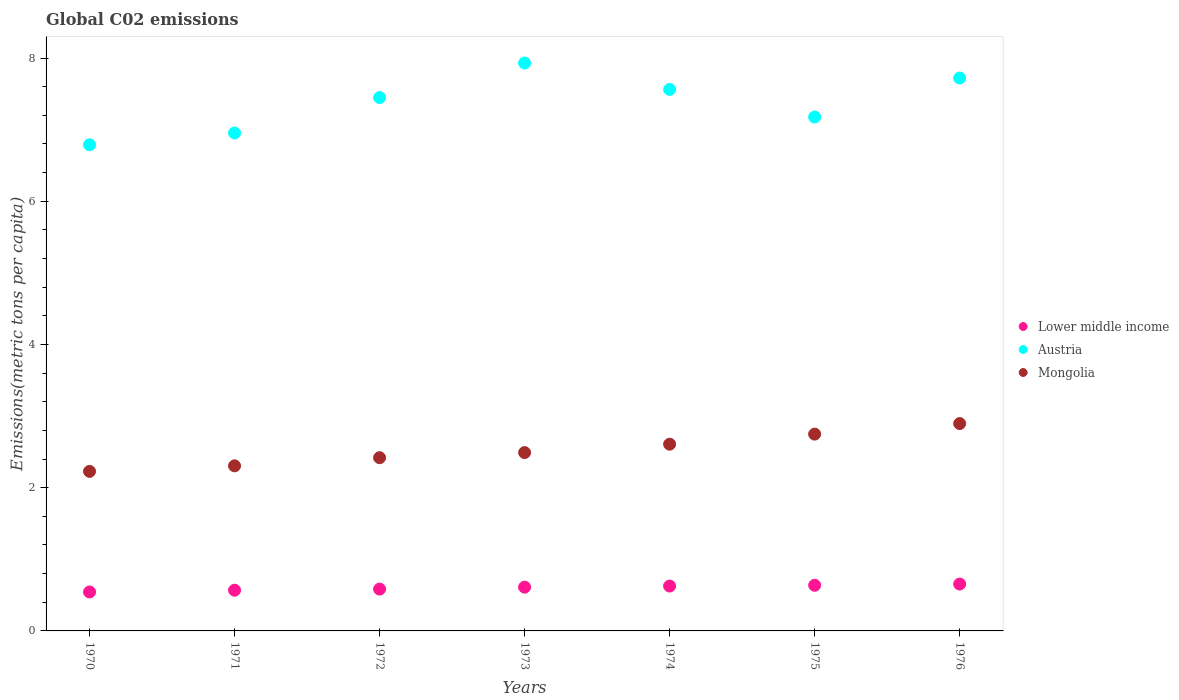What is the amount of CO2 emitted in in Lower middle income in 1975?
Provide a succinct answer. 0.64. Across all years, what is the maximum amount of CO2 emitted in in Mongolia?
Ensure brevity in your answer.  2.9. Across all years, what is the minimum amount of CO2 emitted in in Mongolia?
Offer a terse response. 2.23. In which year was the amount of CO2 emitted in in Lower middle income maximum?
Your response must be concise. 1976. What is the total amount of CO2 emitted in in Lower middle income in the graph?
Offer a very short reply. 4.23. What is the difference between the amount of CO2 emitted in in Mongolia in 1970 and that in 1974?
Make the answer very short. -0.38. What is the difference between the amount of CO2 emitted in in Austria in 1973 and the amount of CO2 emitted in in Mongolia in 1974?
Ensure brevity in your answer.  5.32. What is the average amount of CO2 emitted in in Austria per year?
Provide a succinct answer. 7.37. In the year 1975, what is the difference between the amount of CO2 emitted in in Mongolia and amount of CO2 emitted in in Austria?
Provide a succinct answer. -4.43. What is the ratio of the amount of CO2 emitted in in Lower middle income in 1971 to that in 1973?
Your answer should be compact. 0.93. Is the difference between the amount of CO2 emitted in in Mongolia in 1971 and 1976 greater than the difference between the amount of CO2 emitted in in Austria in 1971 and 1976?
Ensure brevity in your answer.  Yes. What is the difference between the highest and the second highest amount of CO2 emitted in in Lower middle income?
Offer a terse response. 0.02. What is the difference between the highest and the lowest amount of CO2 emitted in in Austria?
Your answer should be compact. 1.14. Is the sum of the amount of CO2 emitted in in Lower middle income in 1971 and 1975 greater than the maximum amount of CO2 emitted in in Mongolia across all years?
Provide a short and direct response. No. Is the amount of CO2 emitted in in Lower middle income strictly less than the amount of CO2 emitted in in Mongolia over the years?
Your answer should be very brief. Yes. How many years are there in the graph?
Provide a short and direct response. 7. What is the difference between two consecutive major ticks on the Y-axis?
Offer a terse response. 2. Are the values on the major ticks of Y-axis written in scientific E-notation?
Offer a very short reply. No. Does the graph contain grids?
Ensure brevity in your answer.  No. Where does the legend appear in the graph?
Offer a terse response. Center right. What is the title of the graph?
Provide a short and direct response. Global C02 emissions. What is the label or title of the X-axis?
Provide a succinct answer. Years. What is the label or title of the Y-axis?
Offer a terse response. Emissions(metric tons per capita). What is the Emissions(metric tons per capita) in Lower middle income in 1970?
Provide a succinct answer. 0.54. What is the Emissions(metric tons per capita) in Austria in 1970?
Keep it short and to the point. 6.79. What is the Emissions(metric tons per capita) of Mongolia in 1970?
Ensure brevity in your answer.  2.23. What is the Emissions(metric tons per capita) of Lower middle income in 1971?
Keep it short and to the point. 0.57. What is the Emissions(metric tons per capita) of Austria in 1971?
Keep it short and to the point. 6.95. What is the Emissions(metric tons per capita) of Mongolia in 1971?
Ensure brevity in your answer.  2.31. What is the Emissions(metric tons per capita) of Lower middle income in 1972?
Your answer should be compact. 0.58. What is the Emissions(metric tons per capita) in Austria in 1972?
Make the answer very short. 7.45. What is the Emissions(metric tons per capita) in Mongolia in 1972?
Your response must be concise. 2.42. What is the Emissions(metric tons per capita) in Lower middle income in 1973?
Your answer should be very brief. 0.61. What is the Emissions(metric tons per capita) of Austria in 1973?
Make the answer very short. 7.93. What is the Emissions(metric tons per capita) in Mongolia in 1973?
Your response must be concise. 2.49. What is the Emissions(metric tons per capita) in Lower middle income in 1974?
Your response must be concise. 0.63. What is the Emissions(metric tons per capita) in Austria in 1974?
Keep it short and to the point. 7.56. What is the Emissions(metric tons per capita) of Mongolia in 1974?
Provide a short and direct response. 2.61. What is the Emissions(metric tons per capita) of Lower middle income in 1975?
Offer a terse response. 0.64. What is the Emissions(metric tons per capita) in Austria in 1975?
Make the answer very short. 7.18. What is the Emissions(metric tons per capita) in Mongolia in 1975?
Keep it short and to the point. 2.75. What is the Emissions(metric tons per capita) in Lower middle income in 1976?
Offer a very short reply. 0.65. What is the Emissions(metric tons per capita) of Austria in 1976?
Your answer should be compact. 7.72. What is the Emissions(metric tons per capita) of Mongolia in 1976?
Give a very brief answer. 2.9. Across all years, what is the maximum Emissions(metric tons per capita) in Lower middle income?
Make the answer very short. 0.65. Across all years, what is the maximum Emissions(metric tons per capita) of Austria?
Give a very brief answer. 7.93. Across all years, what is the maximum Emissions(metric tons per capita) of Mongolia?
Make the answer very short. 2.9. Across all years, what is the minimum Emissions(metric tons per capita) in Lower middle income?
Make the answer very short. 0.54. Across all years, what is the minimum Emissions(metric tons per capita) in Austria?
Offer a terse response. 6.79. Across all years, what is the minimum Emissions(metric tons per capita) of Mongolia?
Give a very brief answer. 2.23. What is the total Emissions(metric tons per capita) of Lower middle income in the graph?
Your answer should be compact. 4.23. What is the total Emissions(metric tons per capita) of Austria in the graph?
Your response must be concise. 51.58. What is the total Emissions(metric tons per capita) in Mongolia in the graph?
Offer a terse response. 17.7. What is the difference between the Emissions(metric tons per capita) in Lower middle income in 1970 and that in 1971?
Provide a succinct answer. -0.02. What is the difference between the Emissions(metric tons per capita) in Austria in 1970 and that in 1971?
Your response must be concise. -0.16. What is the difference between the Emissions(metric tons per capita) in Mongolia in 1970 and that in 1971?
Keep it short and to the point. -0.08. What is the difference between the Emissions(metric tons per capita) in Lower middle income in 1970 and that in 1972?
Offer a very short reply. -0.04. What is the difference between the Emissions(metric tons per capita) of Austria in 1970 and that in 1972?
Your response must be concise. -0.66. What is the difference between the Emissions(metric tons per capita) of Mongolia in 1970 and that in 1972?
Keep it short and to the point. -0.19. What is the difference between the Emissions(metric tons per capita) of Lower middle income in 1970 and that in 1973?
Provide a succinct answer. -0.07. What is the difference between the Emissions(metric tons per capita) of Austria in 1970 and that in 1973?
Give a very brief answer. -1.14. What is the difference between the Emissions(metric tons per capita) of Mongolia in 1970 and that in 1973?
Provide a succinct answer. -0.26. What is the difference between the Emissions(metric tons per capita) of Lower middle income in 1970 and that in 1974?
Provide a short and direct response. -0.08. What is the difference between the Emissions(metric tons per capita) of Austria in 1970 and that in 1974?
Offer a terse response. -0.77. What is the difference between the Emissions(metric tons per capita) of Mongolia in 1970 and that in 1974?
Offer a terse response. -0.38. What is the difference between the Emissions(metric tons per capita) in Lower middle income in 1970 and that in 1975?
Offer a terse response. -0.09. What is the difference between the Emissions(metric tons per capita) in Austria in 1970 and that in 1975?
Your answer should be compact. -0.39. What is the difference between the Emissions(metric tons per capita) in Mongolia in 1970 and that in 1975?
Give a very brief answer. -0.52. What is the difference between the Emissions(metric tons per capita) in Lower middle income in 1970 and that in 1976?
Offer a terse response. -0.11. What is the difference between the Emissions(metric tons per capita) of Austria in 1970 and that in 1976?
Keep it short and to the point. -0.93. What is the difference between the Emissions(metric tons per capita) of Mongolia in 1970 and that in 1976?
Keep it short and to the point. -0.67. What is the difference between the Emissions(metric tons per capita) in Lower middle income in 1971 and that in 1972?
Offer a very short reply. -0.02. What is the difference between the Emissions(metric tons per capita) in Austria in 1971 and that in 1972?
Your answer should be very brief. -0.49. What is the difference between the Emissions(metric tons per capita) of Mongolia in 1971 and that in 1972?
Give a very brief answer. -0.11. What is the difference between the Emissions(metric tons per capita) in Lower middle income in 1971 and that in 1973?
Your answer should be compact. -0.04. What is the difference between the Emissions(metric tons per capita) of Austria in 1971 and that in 1973?
Offer a very short reply. -0.98. What is the difference between the Emissions(metric tons per capita) of Mongolia in 1971 and that in 1973?
Your response must be concise. -0.19. What is the difference between the Emissions(metric tons per capita) in Lower middle income in 1971 and that in 1974?
Make the answer very short. -0.06. What is the difference between the Emissions(metric tons per capita) of Austria in 1971 and that in 1974?
Offer a very short reply. -0.61. What is the difference between the Emissions(metric tons per capita) in Mongolia in 1971 and that in 1974?
Give a very brief answer. -0.3. What is the difference between the Emissions(metric tons per capita) of Lower middle income in 1971 and that in 1975?
Offer a very short reply. -0.07. What is the difference between the Emissions(metric tons per capita) in Austria in 1971 and that in 1975?
Provide a succinct answer. -0.22. What is the difference between the Emissions(metric tons per capita) of Mongolia in 1971 and that in 1975?
Your response must be concise. -0.44. What is the difference between the Emissions(metric tons per capita) of Lower middle income in 1971 and that in 1976?
Your response must be concise. -0.09. What is the difference between the Emissions(metric tons per capita) in Austria in 1971 and that in 1976?
Your answer should be very brief. -0.77. What is the difference between the Emissions(metric tons per capita) of Mongolia in 1971 and that in 1976?
Your response must be concise. -0.59. What is the difference between the Emissions(metric tons per capita) in Lower middle income in 1972 and that in 1973?
Offer a very short reply. -0.03. What is the difference between the Emissions(metric tons per capita) of Austria in 1972 and that in 1973?
Your answer should be compact. -0.48. What is the difference between the Emissions(metric tons per capita) in Mongolia in 1972 and that in 1973?
Keep it short and to the point. -0.07. What is the difference between the Emissions(metric tons per capita) in Lower middle income in 1972 and that in 1974?
Your answer should be compact. -0.04. What is the difference between the Emissions(metric tons per capita) of Austria in 1972 and that in 1974?
Offer a very short reply. -0.11. What is the difference between the Emissions(metric tons per capita) in Mongolia in 1972 and that in 1974?
Your answer should be compact. -0.19. What is the difference between the Emissions(metric tons per capita) of Lower middle income in 1972 and that in 1975?
Make the answer very short. -0.05. What is the difference between the Emissions(metric tons per capita) in Austria in 1972 and that in 1975?
Your answer should be compact. 0.27. What is the difference between the Emissions(metric tons per capita) of Mongolia in 1972 and that in 1975?
Your answer should be very brief. -0.33. What is the difference between the Emissions(metric tons per capita) in Lower middle income in 1972 and that in 1976?
Your response must be concise. -0.07. What is the difference between the Emissions(metric tons per capita) in Austria in 1972 and that in 1976?
Keep it short and to the point. -0.27. What is the difference between the Emissions(metric tons per capita) of Mongolia in 1972 and that in 1976?
Make the answer very short. -0.48. What is the difference between the Emissions(metric tons per capita) in Lower middle income in 1973 and that in 1974?
Provide a succinct answer. -0.02. What is the difference between the Emissions(metric tons per capita) in Austria in 1973 and that in 1974?
Your answer should be compact. 0.37. What is the difference between the Emissions(metric tons per capita) of Mongolia in 1973 and that in 1974?
Provide a succinct answer. -0.12. What is the difference between the Emissions(metric tons per capita) in Lower middle income in 1973 and that in 1975?
Keep it short and to the point. -0.03. What is the difference between the Emissions(metric tons per capita) of Austria in 1973 and that in 1975?
Your answer should be compact. 0.75. What is the difference between the Emissions(metric tons per capita) in Mongolia in 1973 and that in 1975?
Offer a terse response. -0.26. What is the difference between the Emissions(metric tons per capita) of Lower middle income in 1973 and that in 1976?
Make the answer very short. -0.04. What is the difference between the Emissions(metric tons per capita) of Austria in 1973 and that in 1976?
Offer a very short reply. 0.21. What is the difference between the Emissions(metric tons per capita) of Mongolia in 1973 and that in 1976?
Provide a succinct answer. -0.41. What is the difference between the Emissions(metric tons per capita) of Lower middle income in 1974 and that in 1975?
Offer a very short reply. -0.01. What is the difference between the Emissions(metric tons per capita) of Austria in 1974 and that in 1975?
Ensure brevity in your answer.  0.39. What is the difference between the Emissions(metric tons per capita) in Mongolia in 1974 and that in 1975?
Ensure brevity in your answer.  -0.14. What is the difference between the Emissions(metric tons per capita) in Lower middle income in 1974 and that in 1976?
Offer a terse response. -0.03. What is the difference between the Emissions(metric tons per capita) in Austria in 1974 and that in 1976?
Offer a very short reply. -0.16. What is the difference between the Emissions(metric tons per capita) in Mongolia in 1974 and that in 1976?
Make the answer very short. -0.29. What is the difference between the Emissions(metric tons per capita) in Lower middle income in 1975 and that in 1976?
Your answer should be compact. -0.02. What is the difference between the Emissions(metric tons per capita) in Austria in 1975 and that in 1976?
Your answer should be compact. -0.54. What is the difference between the Emissions(metric tons per capita) of Mongolia in 1975 and that in 1976?
Your answer should be very brief. -0.15. What is the difference between the Emissions(metric tons per capita) of Lower middle income in 1970 and the Emissions(metric tons per capita) of Austria in 1971?
Offer a very short reply. -6.41. What is the difference between the Emissions(metric tons per capita) of Lower middle income in 1970 and the Emissions(metric tons per capita) of Mongolia in 1971?
Provide a succinct answer. -1.76. What is the difference between the Emissions(metric tons per capita) in Austria in 1970 and the Emissions(metric tons per capita) in Mongolia in 1971?
Ensure brevity in your answer.  4.48. What is the difference between the Emissions(metric tons per capita) in Lower middle income in 1970 and the Emissions(metric tons per capita) in Austria in 1972?
Your answer should be compact. -6.9. What is the difference between the Emissions(metric tons per capita) in Lower middle income in 1970 and the Emissions(metric tons per capita) in Mongolia in 1972?
Provide a short and direct response. -1.88. What is the difference between the Emissions(metric tons per capita) in Austria in 1970 and the Emissions(metric tons per capita) in Mongolia in 1972?
Keep it short and to the point. 4.37. What is the difference between the Emissions(metric tons per capita) of Lower middle income in 1970 and the Emissions(metric tons per capita) of Austria in 1973?
Your response must be concise. -7.39. What is the difference between the Emissions(metric tons per capita) in Lower middle income in 1970 and the Emissions(metric tons per capita) in Mongolia in 1973?
Offer a very short reply. -1.95. What is the difference between the Emissions(metric tons per capita) of Austria in 1970 and the Emissions(metric tons per capita) of Mongolia in 1973?
Your answer should be very brief. 4.3. What is the difference between the Emissions(metric tons per capita) in Lower middle income in 1970 and the Emissions(metric tons per capita) in Austria in 1974?
Offer a terse response. -7.02. What is the difference between the Emissions(metric tons per capita) of Lower middle income in 1970 and the Emissions(metric tons per capita) of Mongolia in 1974?
Offer a very short reply. -2.06. What is the difference between the Emissions(metric tons per capita) in Austria in 1970 and the Emissions(metric tons per capita) in Mongolia in 1974?
Offer a terse response. 4.18. What is the difference between the Emissions(metric tons per capita) of Lower middle income in 1970 and the Emissions(metric tons per capita) of Austria in 1975?
Keep it short and to the point. -6.63. What is the difference between the Emissions(metric tons per capita) of Lower middle income in 1970 and the Emissions(metric tons per capita) of Mongolia in 1975?
Give a very brief answer. -2.2. What is the difference between the Emissions(metric tons per capita) of Austria in 1970 and the Emissions(metric tons per capita) of Mongolia in 1975?
Offer a very short reply. 4.04. What is the difference between the Emissions(metric tons per capita) of Lower middle income in 1970 and the Emissions(metric tons per capita) of Austria in 1976?
Provide a short and direct response. -7.18. What is the difference between the Emissions(metric tons per capita) in Lower middle income in 1970 and the Emissions(metric tons per capita) in Mongolia in 1976?
Provide a short and direct response. -2.35. What is the difference between the Emissions(metric tons per capita) of Austria in 1970 and the Emissions(metric tons per capita) of Mongolia in 1976?
Provide a short and direct response. 3.89. What is the difference between the Emissions(metric tons per capita) in Lower middle income in 1971 and the Emissions(metric tons per capita) in Austria in 1972?
Your answer should be very brief. -6.88. What is the difference between the Emissions(metric tons per capita) of Lower middle income in 1971 and the Emissions(metric tons per capita) of Mongolia in 1972?
Ensure brevity in your answer.  -1.85. What is the difference between the Emissions(metric tons per capita) of Austria in 1971 and the Emissions(metric tons per capita) of Mongolia in 1972?
Give a very brief answer. 4.53. What is the difference between the Emissions(metric tons per capita) of Lower middle income in 1971 and the Emissions(metric tons per capita) of Austria in 1973?
Ensure brevity in your answer.  -7.36. What is the difference between the Emissions(metric tons per capita) in Lower middle income in 1971 and the Emissions(metric tons per capita) in Mongolia in 1973?
Your answer should be very brief. -1.92. What is the difference between the Emissions(metric tons per capita) of Austria in 1971 and the Emissions(metric tons per capita) of Mongolia in 1973?
Your answer should be compact. 4.46. What is the difference between the Emissions(metric tons per capita) of Lower middle income in 1971 and the Emissions(metric tons per capita) of Austria in 1974?
Keep it short and to the point. -6.99. What is the difference between the Emissions(metric tons per capita) in Lower middle income in 1971 and the Emissions(metric tons per capita) in Mongolia in 1974?
Offer a terse response. -2.04. What is the difference between the Emissions(metric tons per capita) of Austria in 1971 and the Emissions(metric tons per capita) of Mongolia in 1974?
Provide a short and direct response. 4.35. What is the difference between the Emissions(metric tons per capita) in Lower middle income in 1971 and the Emissions(metric tons per capita) in Austria in 1975?
Offer a very short reply. -6.61. What is the difference between the Emissions(metric tons per capita) in Lower middle income in 1971 and the Emissions(metric tons per capita) in Mongolia in 1975?
Offer a terse response. -2.18. What is the difference between the Emissions(metric tons per capita) in Austria in 1971 and the Emissions(metric tons per capita) in Mongolia in 1975?
Offer a very short reply. 4.21. What is the difference between the Emissions(metric tons per capita) of Lower middle income in 1971 and the Emissions(metric tons per capita) of Austria in 1976?
Your answer should be very brief. -7.15. What is the difference between the Emissions(metric tons per capita) of Lower middle income in 1971 and the Emissions(metric tons per capita) of Mongolia in 1976?
Your response must be concise. -2.33. What is the difference between the Emissions(metric tons per capita) in Austria in 1971 and the Emissions(metric tons per capita) in Mongolia in 1976?
Give a very brief answer. 4.06. What is the difference between the Emissions(metric tons per capita) in Lower middle income in 1972 and the Emissions(metric tons per capita) in Austria in 1973?
Provide a short and direct response. -7.35. What is the difference between the Emissions(metric tons per capita) in Lower middle income in 1972 and the Emissions(metric tons per capita) in Mongolia in 1973?
Keep it short and to the point. -1.91. What is the difference between the Emissions(metric tons per capita) in Austria in 1972 and the Emissions(metric tons per capita) in Mongolia in 1973?
Your response must be concise. 4.96. What is the difference between the Emissions(metric tons per capita) of Lower middle income in 1972 and the Emissions(metric tons per capita) of Austria in 1974?
Your answer should be very brief. -6.98. What is the difference between the Emissions(metric tons per capita) of Lower middle income in 1972 and the Emissions(metric tons per capita) of Mongolia in 1974?
Provide a short and direct response. -2.02. What is the difference between the Emissions(metric tons per capita) in Austria in 1972 and the Emissions(metric tons per capita) in Mongolia in 1974?
Your response must be concise. 4.84. What is the difference between the Emissions(metric tons per capita) in Lower middle income in 1972 and the Emissions(metric tons per capita) in Austria in 1975?
Your answer should be compact. -6.59. What is the difference between the Emissions(metric tons per capita) of Lower middle income in 1972 and the Emissions(metric tons per capita) of Mongolia in 1975?
Make the answer very short. -2.16. What is the difference between the Emissions(metric tons per capita) of Austria in 1972 and the Emissions(metric tons per capita) of Mongolia in 1975?
Make the answer very short. 4.7. What is the difference between the Emissions(metric tons per capita) in Lower middle income in 1972 and the Emissions(metric tons per capita) in Austria in 1976?
Offer a terse response. -7.14. What is the difference between the Emissions(metric tons per capita) in Lower middle income in 1972 and the Emissions(metric tons per capita) in Mongolia in 1976?
Provide a succinct answer. -2.31. What is the difference between the Emissions(metric tons per capita) of Austria in 1972 and the Emissions(metric tons per capita) of Mongolia in 1976?
Your answer should be very brief. 4.55. What is the difference between the Emissions(metric tons per capita) of Lower middle income in 1973 and the Emissions(metric tons per capita) of Austria in 1974?
Your answer should be compact. -6.95. What is the difference between the Emissions(metric tons per capita) of Lower middle income in 1973 and the Emissions(metric tons per capita) of Mongolia in 1974?
Your response must be concise. -2. What is the difference between the Emissions(metric tons per capita) of Austria in 1973 and the Emissions(metric tons per capita) of Mongolia in 1974?
Ensure brevity in your answer.  5.32. What is the difference between the Emissions(metric tons per capita) of Lower middle income in 1973 and the Emissions(metric tons per capita) of Austria in 1975?
Your answer should be very brief. -6.57. What is the difference between the Emissions(metric tons per capita) in Lower middle income in 1973 and the Emissions(metric tons per capita) in Mongolia in 1975?
Make the answer very short. -2.14. What is the difference between the Emissions(metric tons per capita) in Austria in 1973 and the Emissions(metric tons per capita) in Mongolia in 1975?
Your response must be concise. 5.18. What is the difference between the Emissions(metric tons per capita) in Lower middle income in 1973 and the Emissions(metric tons per capita) in Austria in 1976?
Keep it short and to the point. -7.11. What is the difference between the Emissions(metric tons per capita) in Lower middle income in 1973 and the Emissions(metric tons per capita) in Mongolia in 1976?
Provide a short and direct response. -2.28. What is the difference between the Emissions(metric tons per capita) in Austria in 1973 and the Emissions(metric tons per capita) in Mongolia in 1976?
Offer a terse response. 5.04. What is the difference between the Emissions(metric tons per capita) of Lower middle income in 1974 and the Emissions(metric tons per capita) of Austria in 1975?
Your answer should be very brief. -6.55. What is the difference between the Emissions(metric tons per capita) of Lower middle income in 1974 and the Emissions(metric tons per capita) of Mongolia in 1975?
Provide a succinct answer. -2.12. What is the difference between the Emissions(metric tons per capita) of Austria in 1974 and the Emissions(metric tons per capita) of Mongolia in 1975?
Your response must be concise. 4.81. What is the difference between the Emissions(metric tons per capita) in Lower middle income in 1974 and the Emissions(metric tons per capita) in Austria in 1976?
Your answer should be compact. -7.09. What is the difference between the Emissions(metric tons per capita) of Lower middle income in 1974 and the Emissions(metric tons per capita) of Mongolia in 1976?
Your response must be concise. -2.27. What is the difference between the Emissions(metric tons per capita) in Austria in 1974 and the Emissions(metric tons per capita) in Mongolia in 1976?
Your response must be concise. 4.67. What is the difference between the Emissions(metric tons per capita) of Lower middle income in 1975 and the Emissions(metric tons per capita) of Austria in 1976?
Offer a very short reply. -7.08. What is the difference between the Emissions(metric tons per capita) of Lower middle income in 1975 and the Emissions(metric tons per capita) of Mongolia in 1976?
Provide a succinct answer. -2.26. What is the difference between the Emissions(metric tons per capita) of Austria in 1975 and the Emissions(metric tons per capita) of Mongolia in 1976?
Give a very brief answer. 4.28. What is the average Emissions(metric tons per capita) of Lower middle income per year?
Keep it short and to the point. 0.6. What is the average Emissions(metric tons per capita) in Austria per year?
Ensure brevity in your answer.  7.37. What is the average Emissions(metric tons per capita) in Mongolia per year?
Ensure brevity in your answer.  2.53. In the year 1970, what is the difference between the Emissions(metric tons per capita) in Lower middle income and Emissions(metric tons per capita) in Austria?
Keep it short and to the point. -6.24. In the year 1970, what is the difference between the Emissions(metric tons per capita) of Lower middle income and Emissions(metric tons per capita) of Mongolia?
Give a very brief answer. -1.68. In the year 1970, what is the difference between the Emissions(metric tons per capita) in Austria and Emissions(metric tons per capita) in Mongolia?
Your answer should be compact. 4.56. In the year 1971, what is the difference between the Emissions(metric tons per capita) in Lower middle income and Emissions(metric tons per capita) in Austria?
Your response must be concise. -6.39. In the year 1971, what is the difference between the Emissions(metric tons per capita) of Lower middle income and Emissions(metric tons per capita) of Mongolia?
Offer a very short reply. -1.74. In the year 1971, what is the difference between the Emissions(metric tons per capita) of Austria and Emissions(metric tons per capita) of Mongolia?
Your answer should be very brief. 4.65. In the year 1972, what is the difference between the Emissions(metric tons per capita) in Lower middle income and Emissions(metric tons per capita) in Austria?
Make the answer very short. -6.86. In the year 1972, what is the difference between the Emissions(metric tons per capita) in Lower middle income and Emissions(metric tons per capita) in Mongolia?
Ensure brevity in your answer.  -1.83. In the year 1972, what is the difference between the Emissions(metric tons per capita) in Austria and Emissions(metric tons per capita) in Mongolia?
Provide a short and direct response. 5.03. In the year 1973, what is the difference between the Emissions(metric tons per capita) of Lower middle income and Emissions(metric tons per capita) of Austria?
Ensure brevity in your answer.  -7.32. In the year 1973, what is the difference between the Emissions(metric tons per capita) of Lower middle income and Emissions(metric tons per capita) of Mongolia?
Provide a short and direct response. -1.88. In the year 1973, what is the difference between the Emissions(metric tons per capita) of Austria and Emissions(metric tons per capita) of Mongolia?
Make the answer very short. 5.44. In the year 1974, what is the difference between the Emissions(metric tons per capita) of Lower middle income and Emissions(metric tons per capita) of Austria?
Provide a succinct answer. -6.94. In the year 1974, what is the difference between the Emissions(metric tons per capita) in Lower middle income and Emissions(metric tons per capita) in Mongolia?
Offer a very short reply. -1.98. In the year 1974, what is the difference between the Emissions(metric tons per capita) in Austria and Emissions(metric tons per capita) in Mongolia?
Ensure brevity in your answer.  4.95. In the year 1975, what is the difference between the Emissions(metric tons per capita) of Lower middle income and Emissions(metric tons per capita) of Austria?
Ensure brevity in your answer.  -6.54. In the year 1975, what is the difference between the Emissions(metric tons per capita) of Lower middle income and Emissions(metric tons per capita) of Mongolia?
Offer a terse response. -2.11. In the year 1975, what is the difference between the Emissions(metric tons per capita) in Austria and Emissions(metric tons per capita) in Mongolia?
Your response must be concise. 4.43. In the year 1976, what is the difference between the Emissions(metric tons per capita) of Lower middle income and Emissions(metric tons per capita) of Austria?
Make the answer very short. -7.07. In the year 1976, what is the difference between the Emissions(metric tons per capita) in Lower middle income and Emissions(metric tons per capita) in Mongolia?
Your answer should be compact. -2.24. In the year 1976, what is the difference between the Emissions(metric tons per capita) in Austria and Emissions(metric tons per capita) in Mongolia?
Your answer should be compact. 4.83. What is the ratio of the Emissions(metric tons per capita) of Austria in 1970 to that in 1971?
Give a very brief answer. 0.98. What is the ratio of the Emissions(metric tons per capita) of Mongolia in 1970 to that in 1971?
Ensure brevity in your answer.  0.97. What is the ratio of the Emissions(metric tons per capita) of Lower middle income in 1970 to that in 1972?
Provide a succinct answer. 0.93. What is the ratio of the Emissions(metric tons per capita) of Austria in 1970 to that in 1972?
Offer a very short reply. 0.91. What is the ratio of the Emissions(metric tons per capita) of Mongolia in 1970 to that in 1972?
Your response must be concise. 0.92. What is the ratio of the Emissions(metric tons per capita) of Lower middle income in 1970 to that in 1973?
Give a very brief answer. 0.89. What is the ratio of the Emissions(metric tons per capita) of Austria in 1970 to that in 1973?
Give a very brief answer. 0.86. What is the ratio of the Emissions(metric tons per capita) in Mongolia in 1970 to that in 1973?
Provide a succinct answer. 0.89. What is the ratio of the Emissions(metric tons per capita) of Lower middle income in 1970 to that in 1974?
Your response must be concise. 0.87. What is the ratio of the Emissions(metric tons per capita) of Austria in 1970 to that in 1974?
Your answer should be very brief. 0.9. What is the ratio of the Emissions(metric tons per capita) of Mongolia in 1970 to that in 1974?
Your answer should be very brief. 0.85. What is the ratio of the Emissions(metric tons per capita) in Lower middle income in 1970 to that in 1975?
Keep it short and to the point. 0.85. What is the ratio of the Emissions(metric tons per capita) of Austria in 1970 to that in 1975?
Make the answer very short. 0.95. What is the ratio of the Emissions(metric tons per capita) of Mongolia in 1970 to that in 1975?
Keep it short and to the point. 0.81. What is the ratio of the Emissions(metric tons per capita) of Lower middle income in 1970 to that in 1976?
Provide a succinct answer. 0.83. What is the ratio of the Emissions(metric tons per capita) in Austria in 1970 to that in 1976?
Offer a very short reply. 0.88. What is the ratio of the Emissions(metric tons per capita) of Mongolia in 1970 to that in 1976?
Your answer should be compact. 0.77. What is the ratio of the Emissions(metric tons per capita) of Lower middle income in 1971 to that in 1972?
Your response must be concise. 0.97. What is the ratio of the Emissions(metric tons per capita) of Austria in 1971 to that in 1972?
Make the answer very short. 0.93. What is the ratio of the Emissions(metric tons per capita) of Mongolia in 1971 to that in 1972?
Provide a succinct answer. 0.95. What is the ratio of the Emissions(metric tons per capita) in Lower middle income in 1971 to that in 1973?
Your answer should be very brief. 0.93. What is the ratio of the Emissions(metric tons per capita) of Austria in 1971 to that in 1973?
Keep it short and to the point. 0.88. What is the ratio of the Emissions(metric tons per capita) of Mongolia in 1971 to that in 1973?
Your answer should be compact. 0.93. What is the ratio of the Emissions(metric tons per capita) of Lower middle income in 1971 to that in 1974?
Your response must be concise. 0.91. What is the ratio of the Emissions(metric tons per capita) in Austria in 1971 to that in 1974?
Your answer should be compact. 0.92. What is the ratio of the Emissions(metric tons per capita) in Mongolia in 1971 to that in 1974?
Your answer should be compact. 0.88. What is the ratio of the Emissions(metric tons per capita) of Lower middle income in 1971 to that in 1975?
Offer a terse response. 0.89. What is the ratio of the Emissions(metric tons per capita) in Austria in 1971 to that in 1975?
Ensure brevity in your answer.  0.97. What is the ratio of the Emissions(metric tons per capita) of Mongolia in 1971 to that in 1975?
Give a very brief answer. 0.84. What is the ratio of the Emissions(metric tons per capita) of Lower middle income in 1971 to that in 1976?
Provide a succinct answer. 0.87. What is the ratio of the Emissions(metric tons per capita) of Austria in 1971 to that in 1976?
Provide a short and direct response. 0.9. What is the ratio of the Emissions(metric tons per capita) of Mongolia in 1971 to that in 1976?
Your answer should be very brief. 0.8. What is the ratio of the Emissions(metric tons per capita) in Lower middle income in 1972 to that in 1973?
Make the answer very short. 0.96. What is the ratio of the Emissions(metric tons per capita) of Austria in 1972 to that in 1973?
Your answer should be compact. 0.94. What is the ratio of the Emissions(metric tons per capita) of Mongolia in 1972 to that in 1973?
Offer a terse response. 0.97. What is the ratio of the Emissions(metric tons per capita) of Lower middle income in 1972 to that in 1974?
Keep it short and to the point. 0.93. What is the ratio of the Emissions(metric tons per capita) in Austria in 1972 to that in 1974?
Offer a terse response. 0.98. What is the ratio of the Emissions(metric tons per capita) in Mongolia in 1972 to that in 1974?
Your answer should be compact. 0.93. What is the ratio of the Emissions(metric tons per capita) of Lower middle income in 1972 to that in 1975?
Provide a succinct answer. 0.92. What is the ratio of the Emissions(metric tons per capita) in Austria in 1972 to that in 1975?
Provide a succinct answer. 1.04. What is the ratio of the Emissions(metric tons per capita) in Mongolia in 1972 to that in 1975?
Offer a very short reply. 0.88. What is the ratio of the Emissions(metric tons per capita) in Lower middle income in 1972 to that in 1976?
Your answer should be very brief. 0.89. What is the ratio of the Emissions(metric tons per capita) of Austria in 1972 to that in 1976?
Offer a terse response. 0.96. What is the ratio of the Emissions(metric tons per capita) of Mongolia in 1972 to that in 1976?
Offer a very short reply. 0.84. What is the ratio of the Emissions(metric tons per capita) in Lower middle income in 1973 to that in 1974?
Your response must be concise. 0.98. What is the ratio of the Emissions(metric tons per capita) of Austria in 1973 to that in 1974?
Keep it short and to the point. 1.05. What is the ratio of the Emissions(metric tons per capita) in Mongolia in 1973 to that in 1974?
Give a very brief answer. 0.95. What is the ratio of the Emissions(metric tons per capita) in Lower middle income in 1973 to that in 1975?
Give a very brief answer. 0.96. What is the ratio of the Emissions(metric tons per capita) of Austria in 1973 to that in 1975?
Provide a succinct answer. 1.11. What is the ratio of the Emissions(metric tons per capita) of Mongolia in 1973 to that in 1975?
Provide a succinct answer. 0.91. What is the ratio of the Emissions(metric tons per capita) of Lower middle income in 1973 to that in 1976?
Make the answer very short. 0.93. What is the ratio of the Emissions(metric tons per capita) in Austria in 1973 to that in 1976?
Provide a succinct answer. 1.03. What is the ratio of the Emissions(metric tons per capita) of Mongolia in 1973 to that in 1976?
Your answer should be compact. 0.86. What is the ratio of the Emissions(metric tons per capita) of Lower middle income in 1974 to that in 1975?
Make the answer very short. 0.98. What is the ratio of the Emissions(metric tons per capita) in Austria in 1974 to that in 1975?
Keep it short and to the point. 1.05. What is the ratio of the Emissions(metric tons per capita) of Mongolia in 1974 to that in 1975?
Offer a very short reply. 0.95. What is the ratio of the Emissions(metric tons per capita) in Lower middle income in 1974 to that in 1976?
Ensure brevity in your answer.  0.96. What is the ratio of the Emissions(metric tons per capita) in Austria in 1974 to that in 1976?
Your response must be concise. 0.98. What is the ratio of the Emissions(metric tons per capita) of Mongolia in 1974 to that in 1976?
Your response must be concise. 0.9. What is the ratio of the Emissions(metric tons per capita) in Lower middle income in 1975 to that in 1976?
Keep it short and to the point. 0.97. What is the ratio of the Emissions(metric tons per capita) in Austria in 1975 to that in 1976?
Your answer should be compact. 0.93. What is the ratio of the Emissions(metric tons per capita) of Mongolia in 1975 to that in 1976?
Provide a succinct answer. 0.95. What is the difference between the highest and the second highest Emissions(metric tons per capita) in Lower middle income?
Your response must be concise. 0.02. What is the difference between the highest and the second highest Emissions(metric tons per capita) of Austria?
Keep it short and to the point. 0.21. What is the difference between the highest and the second highest Emissions(metric tons per capita) of Mongolia?
Provide a short and direct response. 0.15. What is the difference between the highest and the lowest Emissions(metric tons per capita) of Lower middle income?
Your response must be concise. 0.11. What is the difference between the highest and the lowest Emissions(metric tons per capita) of Austria?
Provide a succinct answer. 1.14. What is the difference between the highest and the lowest Emissions(metric tons per capita) in Mongolia?
Your answer should be compact. 0.67. 